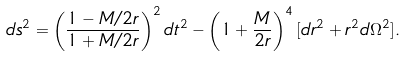<formula> <loc_0><loc_0><loc_500><loc_500>d s ^ { 2 } = \left ( \frac { 1 - M / 2 r } { 1 + M / 2 r } \right ) ^ { 2 } d t ^ { 2 } - \left ( 1 + \frac { M } { 2 r } \right ) ^ { 4 } [ d r ^ { 2 } + r ^ { 2 } d \Omega ^ { 2 } ] .</formula> 